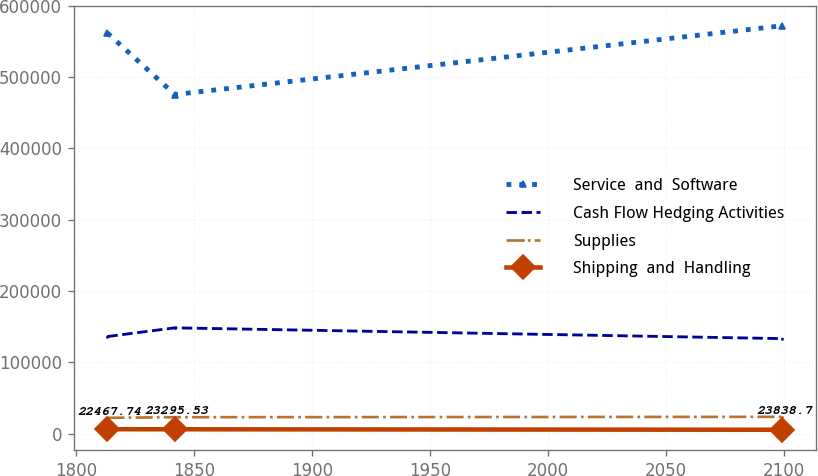Convert chart to OTSL. <chart><loc_0><loc_0><loc_500><loc_500><line_chart><ecel><fcel>Service  and  Software<fcel>Cash Flow Hedging Activities<fcel>Supplies<fcel>Shipping  and  Handling<nl><fcel>1813.08<fcel>561648<fcel>136314<fcel>22467.7<fcel>6462.59<nl><fcel>1841.71<fcel>475379<fcel>148503<fcel>23295.5<fcel>6391.86<nl><fcel>2099.43<fcel>571746<fcel>133411<fcel>23838.7<fcel>5722.57<nl></chart> 